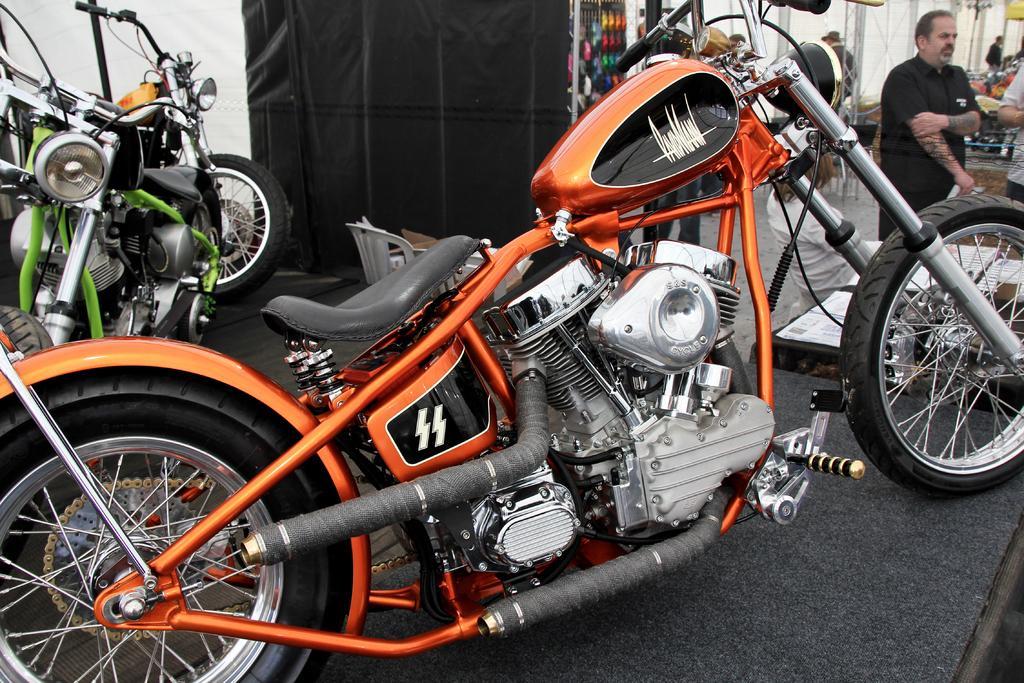Can you describe this image briefly? In this picture we can observe an orange color bike parked here. On the left side there are other two bikes parked. One is in green color. On the right side there is a person standing wearing a black color dress. In the background we can observe some people standing. We can observe black color cloth here. 